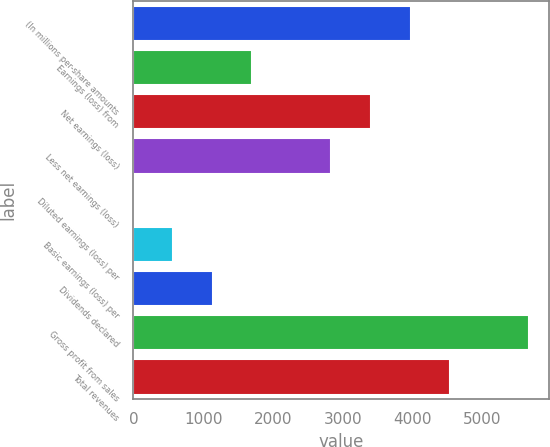Convert chart. <chart><loc_0><loc_0><loc_500><loc_500><bar_chart><fcel>(In millions per-share amounts<fcel>Earnings (loss) from<fcel>Net earnings (loss)<fcel>Less net earnings (loss)<fcel>Diluted earnings (loss) per<fcel>Basic earnings (loss) per<fcel>Dividends declared<fcel>Gross profit from sales<fcel>Total revenues<nl><fcel>3973.22<fcel>1702.9<fcel>3405.64<fcel>2838.06<fcel>0.16<fcel>567.74<fcel>1135.32<fcel>5676<fcel>4540.8<nl></chart> 